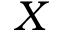Convert formula to latex. <formula><loc_0><loc_0><loc_500><loc_500>X</formula> 